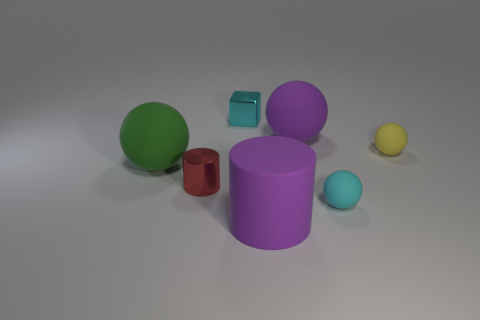What shape is the large matte object that is in front of the red metallic object?
Offer a very short reply. Cylinder. What is the shape of the rubber object that is both in front of the green sphere and behind the large purple cylinder?
Offer a terse response. Sphere. How many blue things are large cubes or large rubber balls?
Your response must be concise. 0. There is a large rubber thing in front of the cyan ball; does it have the same color as the block?
Your response must be concise. No. What is the size of the rubber object that is left of the purple matte thing to the left of the large purple rubber sphere?
Give a very brief answer. Large. There is a cyan cube that is the same size as the red thing; what is it made of?
Your answer should be very brief. Metal. What number of other things are the same size as the purple rubber cylinder?
Provide a succinct answer. 2. What number of balls are either yellow rubber things or cyan things?
Provide a succinct answer. 2. Is there any other thing that is made of the same material as the small block?
Provide a short and direct response. Yes. The large purple thing in front of the shiny object that is in front of the metallic thing that is behind the big purple sphere is made of what material?
Offer a terse response. Rubber. 